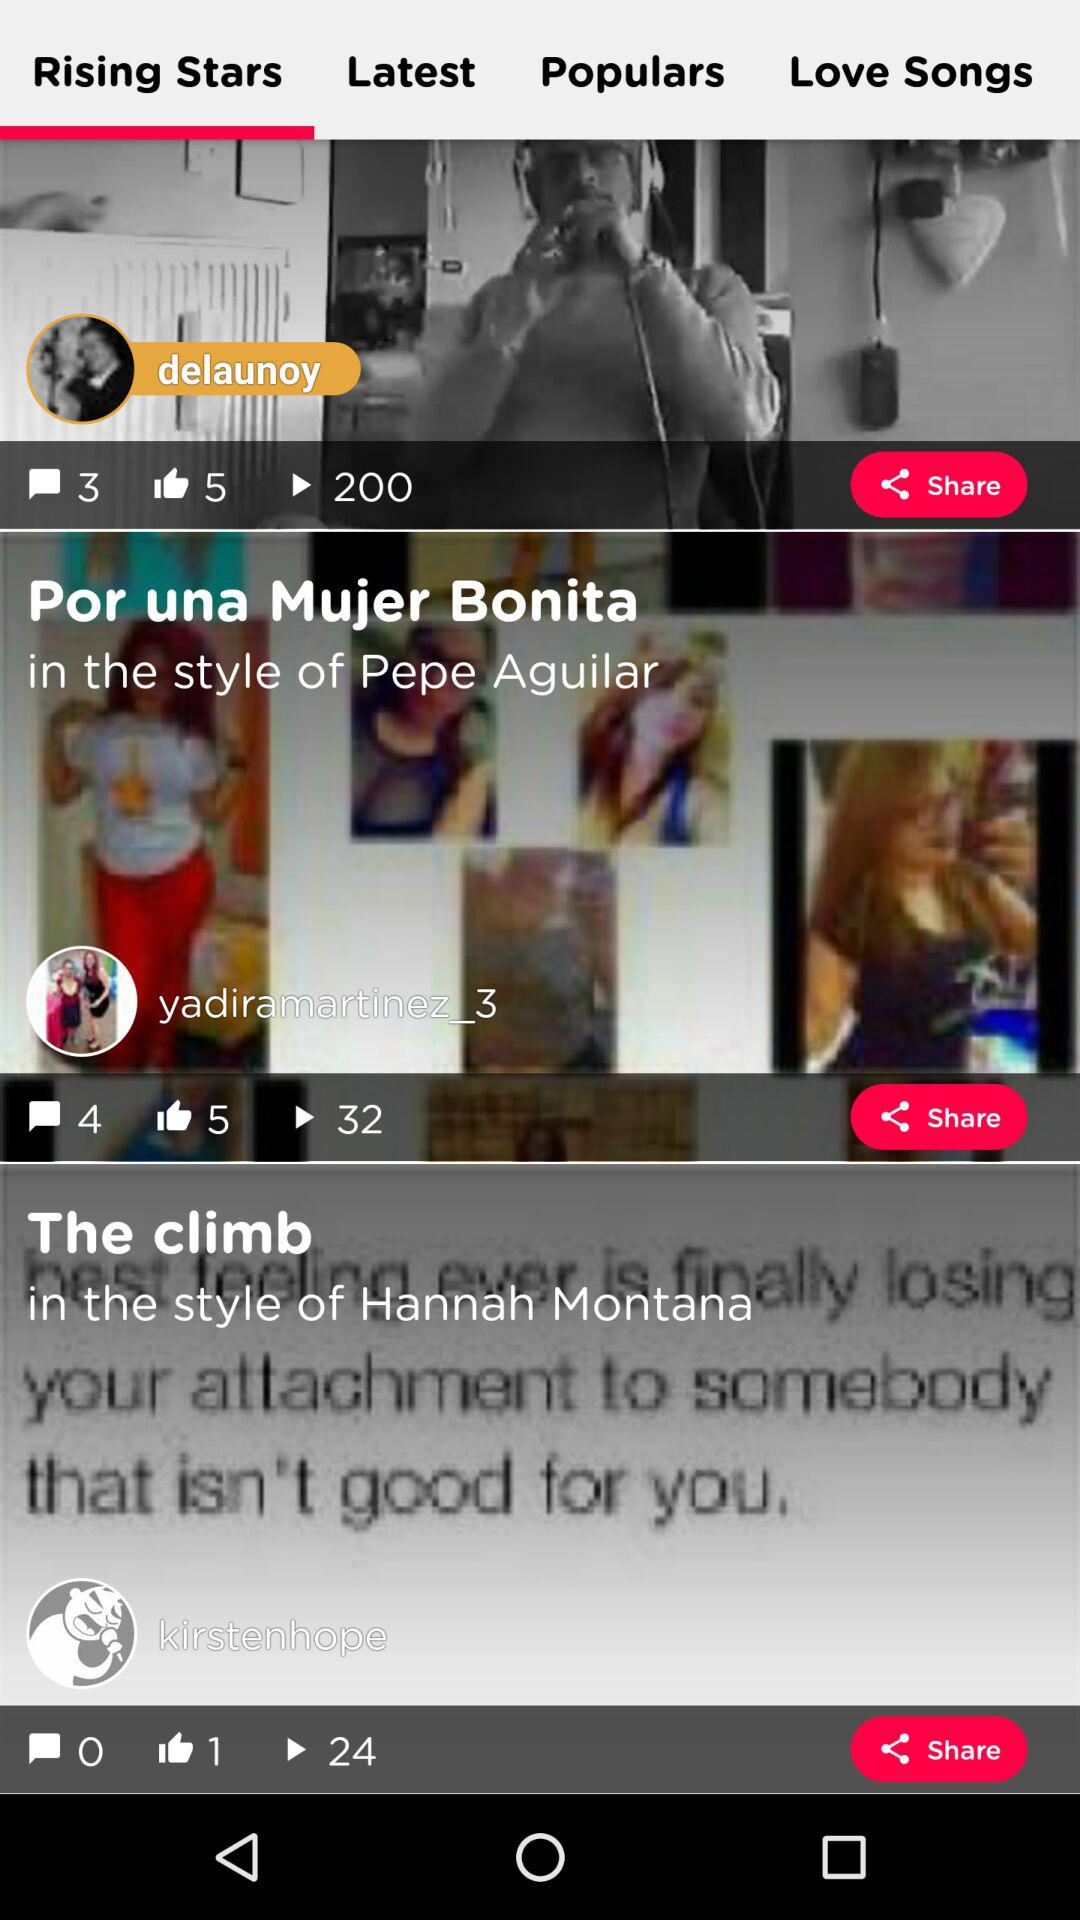How many comments are there on "Por una Mujer Bonita" post? There are 4 comments. 